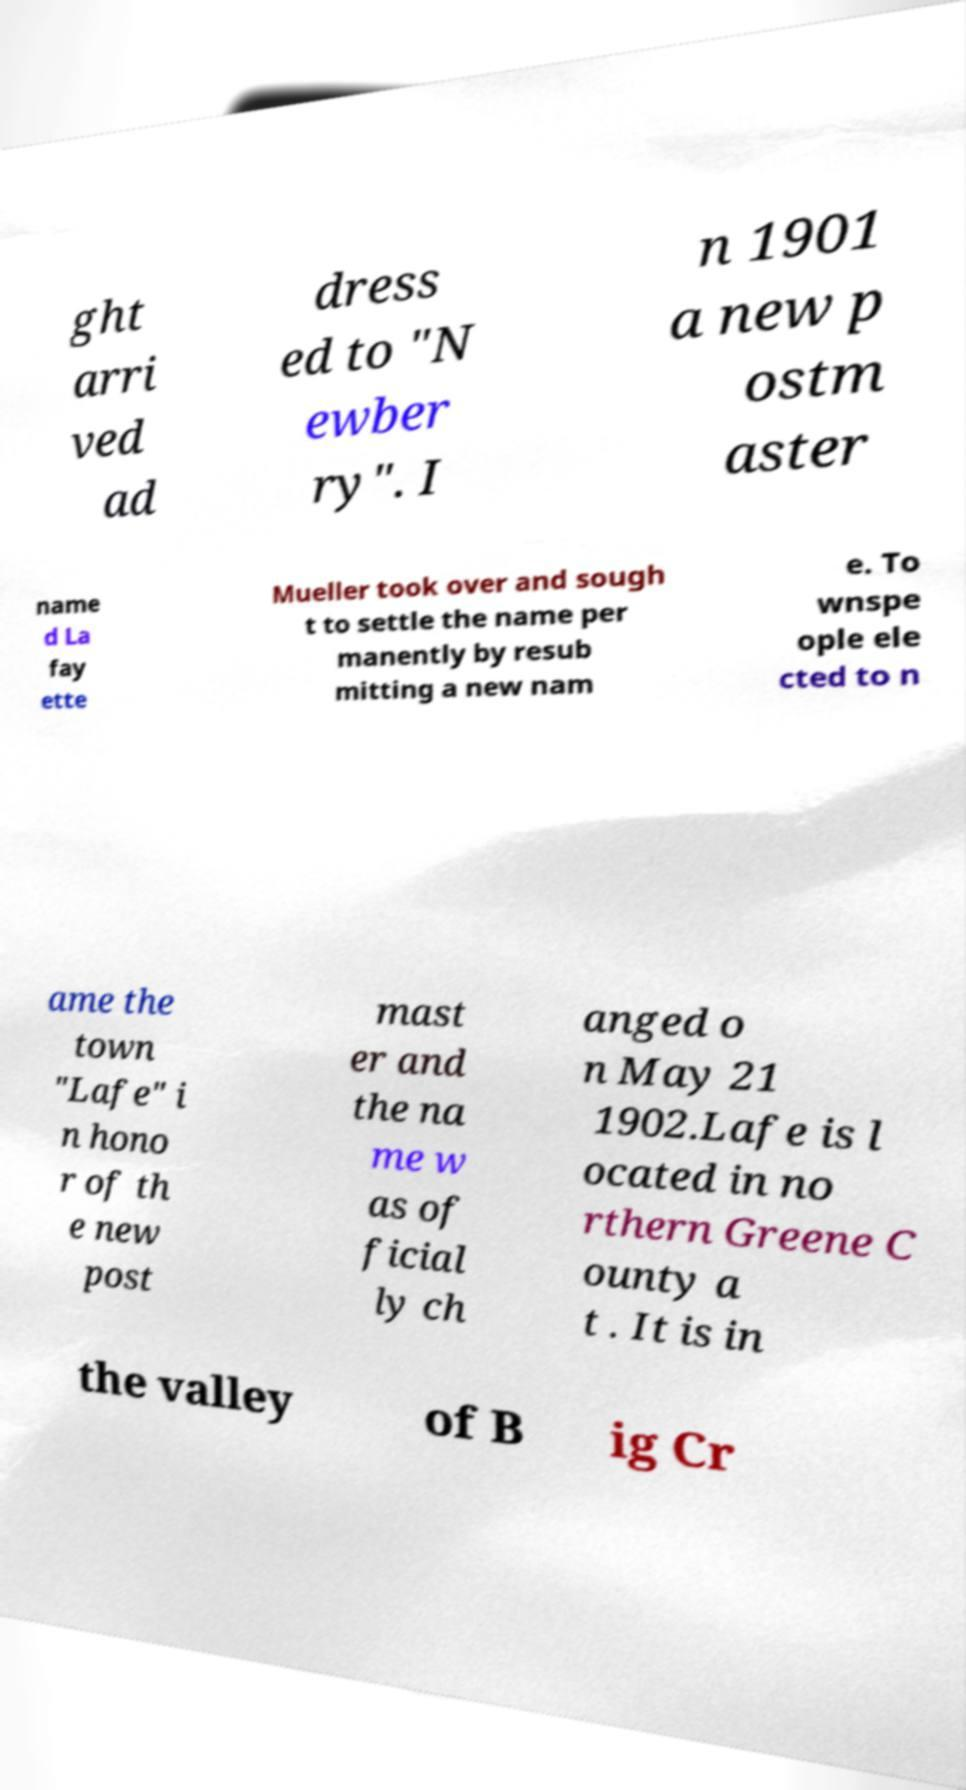What messages or text are displayed in this image? I need them in a readable, typed format. ght arri ved ad dress ed to "N ewber ry". I n 1901 a new p ostm aster name d La fay ette Mueller took over and sough t to settle the name per manently by resub mitting a new nam e. To wnspe ople ele cted to n ame the town "Lafe" i n hono r of th e new post mast er and the na me w as of ficial ly ch anged o n May 21 1902.Lafe is l ocated in no rthern Greene C ounty a t . It is in the valley of B ig Cr 